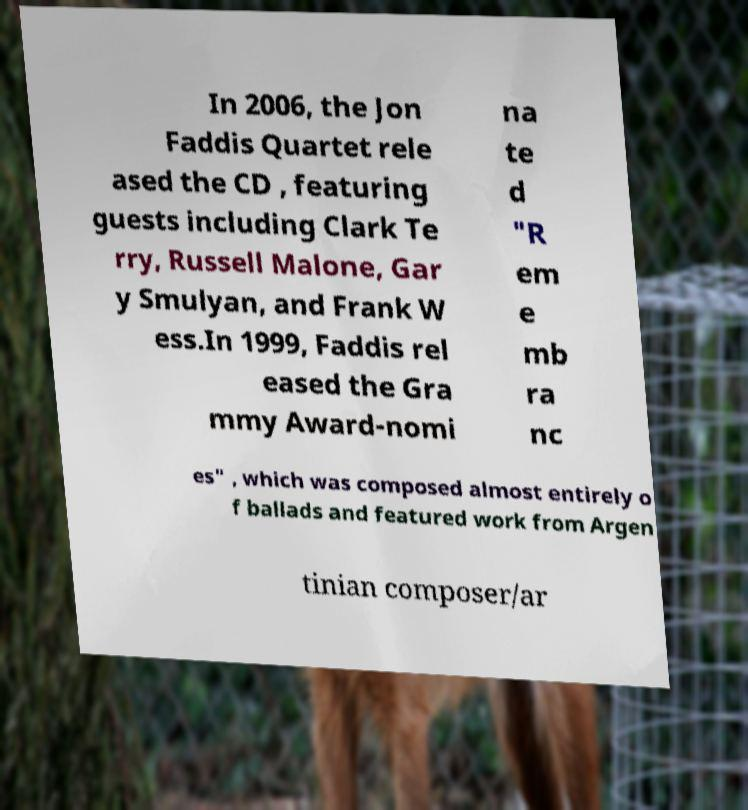Could you assist in decoding the text presented in this image and type it out clearly? In 2006, the Jon Faddis Quartet rele ased the CD , featuring guests including Clark Te rry, Russell Malone, Gar y Smulyan, and Frank W ess.In 1999, Faddis rel eased the Gra mmy Award-nomi na te d "R em e mb ra nc es" , which was composed almost entirely o f ballads and featured work from Argen tinian composer/ar 